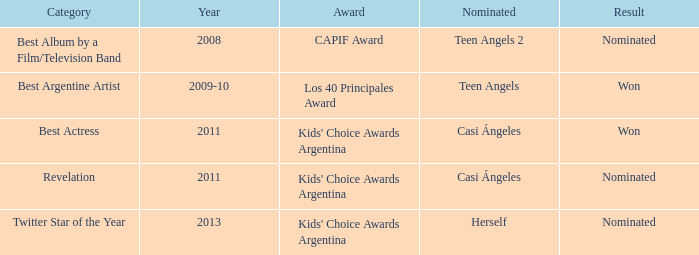What year was Teen Angels 2 nominated? 2008.0. 